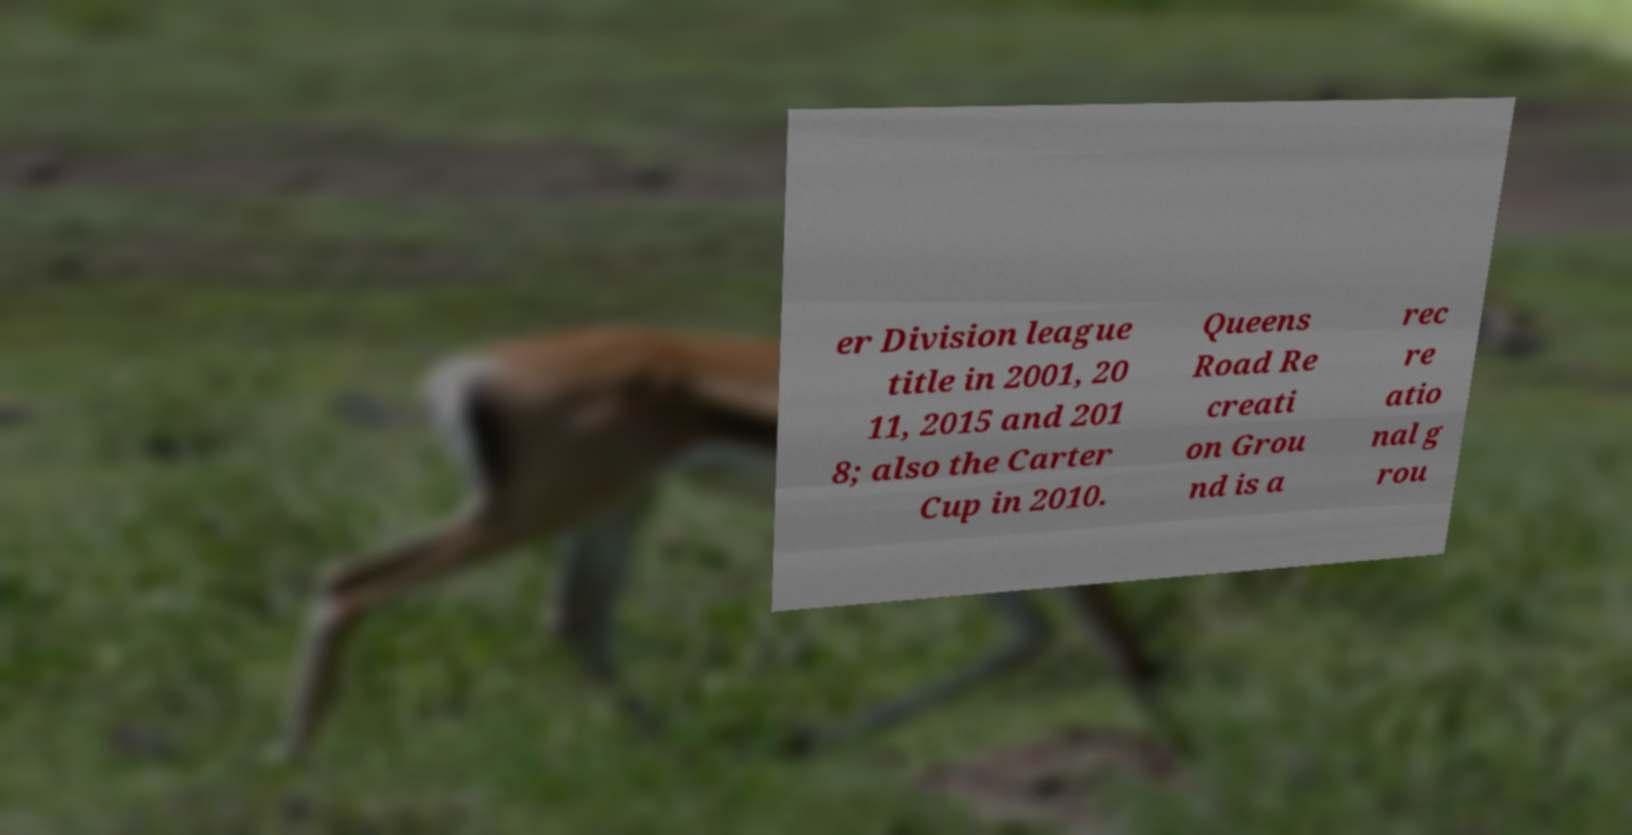Can you accurately transcribe the text from the provided image for me? er Division league title in 2001, 20 11, 2015 and 201 8; also the Carter Cup in 2010. Queens Road Re creati on Grou nd is a rec re atio nal g rou 